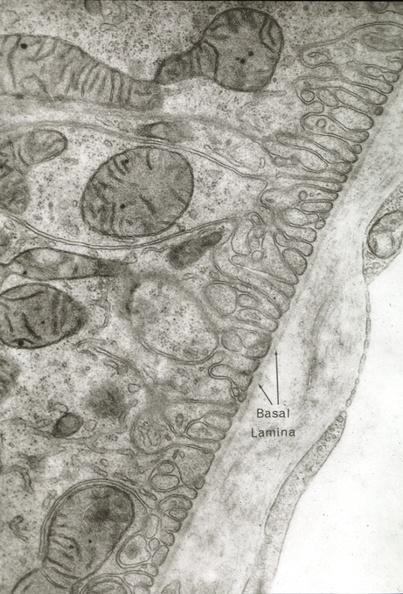s lymphangiomatosis generalized present?
Answer the question using a single word or phrase. No 